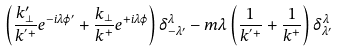Convert formula to latex. <formula><loc_0><loc_0><loc_500><loc_500>\left ( \frac { k ^ { \prime } _ { \perp } } { k ^ { ^ { \prime } + } } e ^ { - i \lambda \varphi ^ { \prime } } + \frac { k _ { \perp } } { k ^ { + } } e ^ { + i \lambda \varphi } \right ) \delta ^ { \lambda } _ { - \lambda ^ { \prime } } - m \lambda \left ( \frac { 1 } { k ^ { ^ { \prime } + } } + \frac { 1 } { k ^ { + } } \right ) \delta ^ { \lambda } _ { \lambda ^ { \prime } }</formula> 